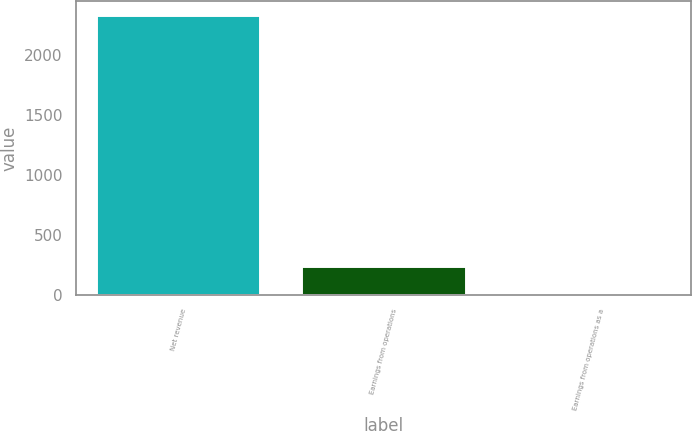Convert chart. <chart><loc_0><loc_0><loc_500><loc_500><bar_chart><fcel>Net revenue<fcel>Earnings from operations<fcel>Earnings from operations as a<nl><fcel>2336<fcel>239.54<fcel>6.6<nl></chart> 